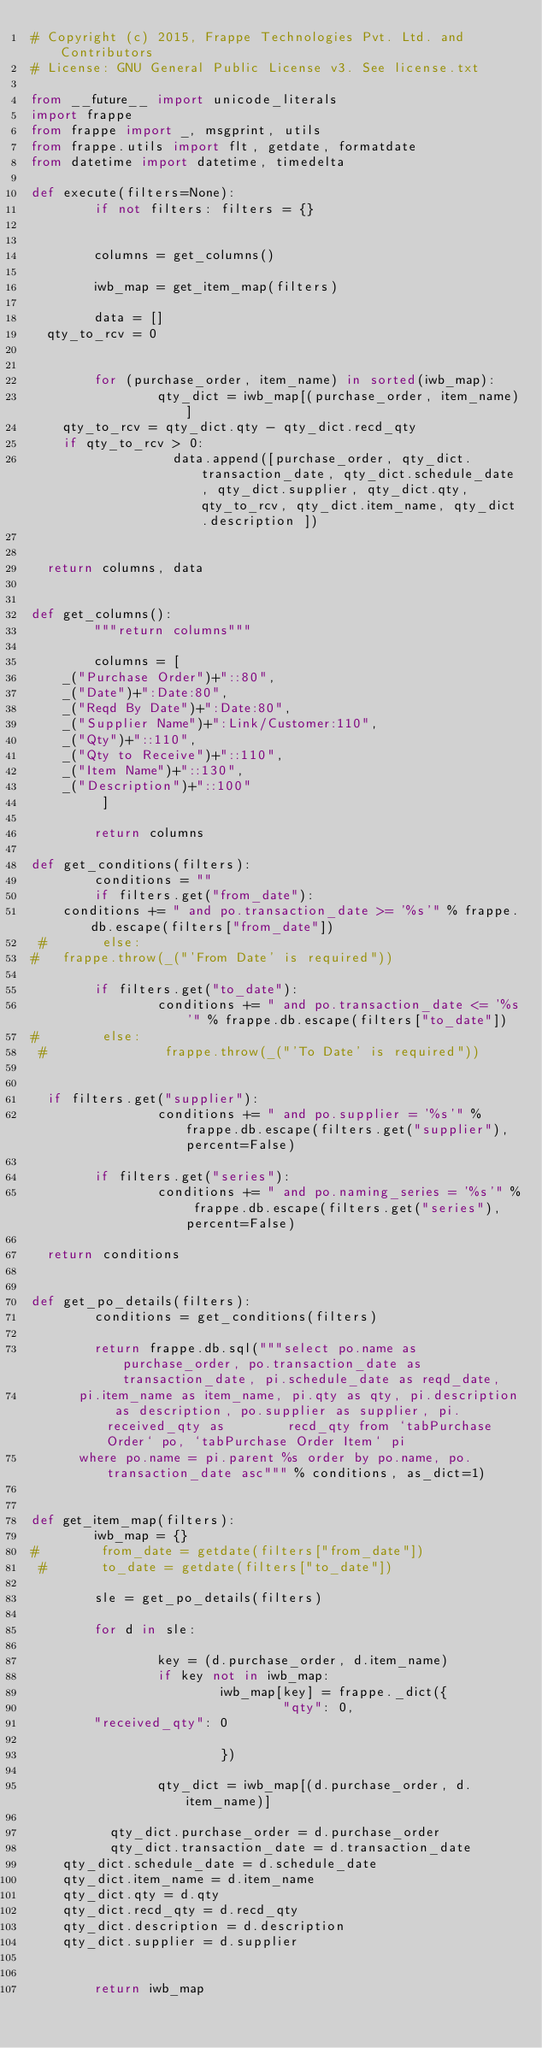Convert code to text. <code><loc_0><loc_0><loc_500><loc_500><_Python_># Copyright (c) 2015, Frappe Technologies Pvt. Ltd. and Contributors
# License: GNU General Public License v3. See license.txt

from __future__ import unicode_literals
import frappe
from frappe import _, msgprint, utils
from frappe.utils import flt, getdate, formatdate
from datetime import datetime, timedelta

def execute(filters=None):
        if not filters: filters = {}

       
        columns = get_columns()
       
        iwb_map = get_item_map(filters)

        data = []
	qty_to_rcv = 0
		

        for (purchase_order, item_name) in sorted(iwb_map):
                qty_dict = iwb_map[(purchase_order, item_name)]
		qty_to_rcv = qty_dict.qty - qty_dict.recd_qty
		if qty_to_rcv > 0:
	                data.append([purchase_order, qty_dict.transaction_date, qty_dict.schedule_date, qty_dict.supplier, qty_dict.qty, qty_to_rcv, qty_dict.item_name, qty_dict.description ])

						 
	return columns, data 


def get_columns():
        """return columns"""
               
        columns = [
		_("Purchase Order")+"::80",		
		_("Date")+":Date:80",
		_("Reqd By Date")+":Date:80",
		_("Supplier Name")+":Link/Customer:110",
		_("Qty")+"::110",
		_("Qty to Receive")+"::110",
		_("Item Name")+"::130",
		_("Description")+"::100"
         ]

        return columns

def get_conditions(filters):
        conditions = ""
        if filters.get("from_date"):
		conditions += " and po.transaction_date >= '%s'" % frappe.db.escape(filters["from_date"])
 #       else:
#		frappe.throw(_("'From Date' is required"))	

        if filters.get("to_date"):
                conditions += " and po.transaction_date <= '%s'" % frappe.db.escape(filters["to_date"])
#        else:
 #               frappe.throw(_("'To Date' is required"))
   
	
	if filters.get("supplier"):
                conditions += " and po.supplier = '%s'" % frappe.db.escape(filters.get("supplier"), percent=False)

        if filters.get("series"):
                conditions += " and po.naming_series = '%s'" % frappe.db.escape(filters.get("series"), percent=False)

	return conditions


def get_po_details(filters):
        conditions = get_conditions(filters)
	
        return frappe.db.sql("""select po.name as purchase_order, po.transaction_date as transaction_date, pi.schedule_date as reqd_date, 
			pi.item_name as item_name, pi.qty as qty, pi.description as description, po.supplier as supplier, pi.received_qty as 				recd_qty from `tabPurchase Order` po, `tabPurchase Order Item` pi
			where po.name = pi.parent %s order by po.name, po.transaction_date asc""" % conditions, as_dict=1)


def get_item_map(filters):
        iwb_map = {}
#        from_date = getdate(filters["from_date"])
 #       to_date = getdate(filters["to_date"])
	
        sle = get_po_details(filters)

        for d in sle:
                
                key = (d.purchase_order, d.item_name)
                if key not in iwb_map:
                        iwb_map[key] = frappe._dict({
                                "qty": 0,
				"received_qty": 0
				
                        })

                qty_dict = iwb_map[(d.purchase_order, d.item_name)]

	        qty_dict.purchase_order = d.purchase_order
	        qty_dict.transaction_date = d.transaction_date
		qty_dict.schedule_date = d.schedule_date
		qty_dict.item_name = d.item_name
		qty_dict.qty = d.qty
		qty_dict.recd_qty = d.recd_qty
		qty_dict.description = d.description
		qty_dict.supplier = d.supplier
		
      
        return iwb_map



</code> 